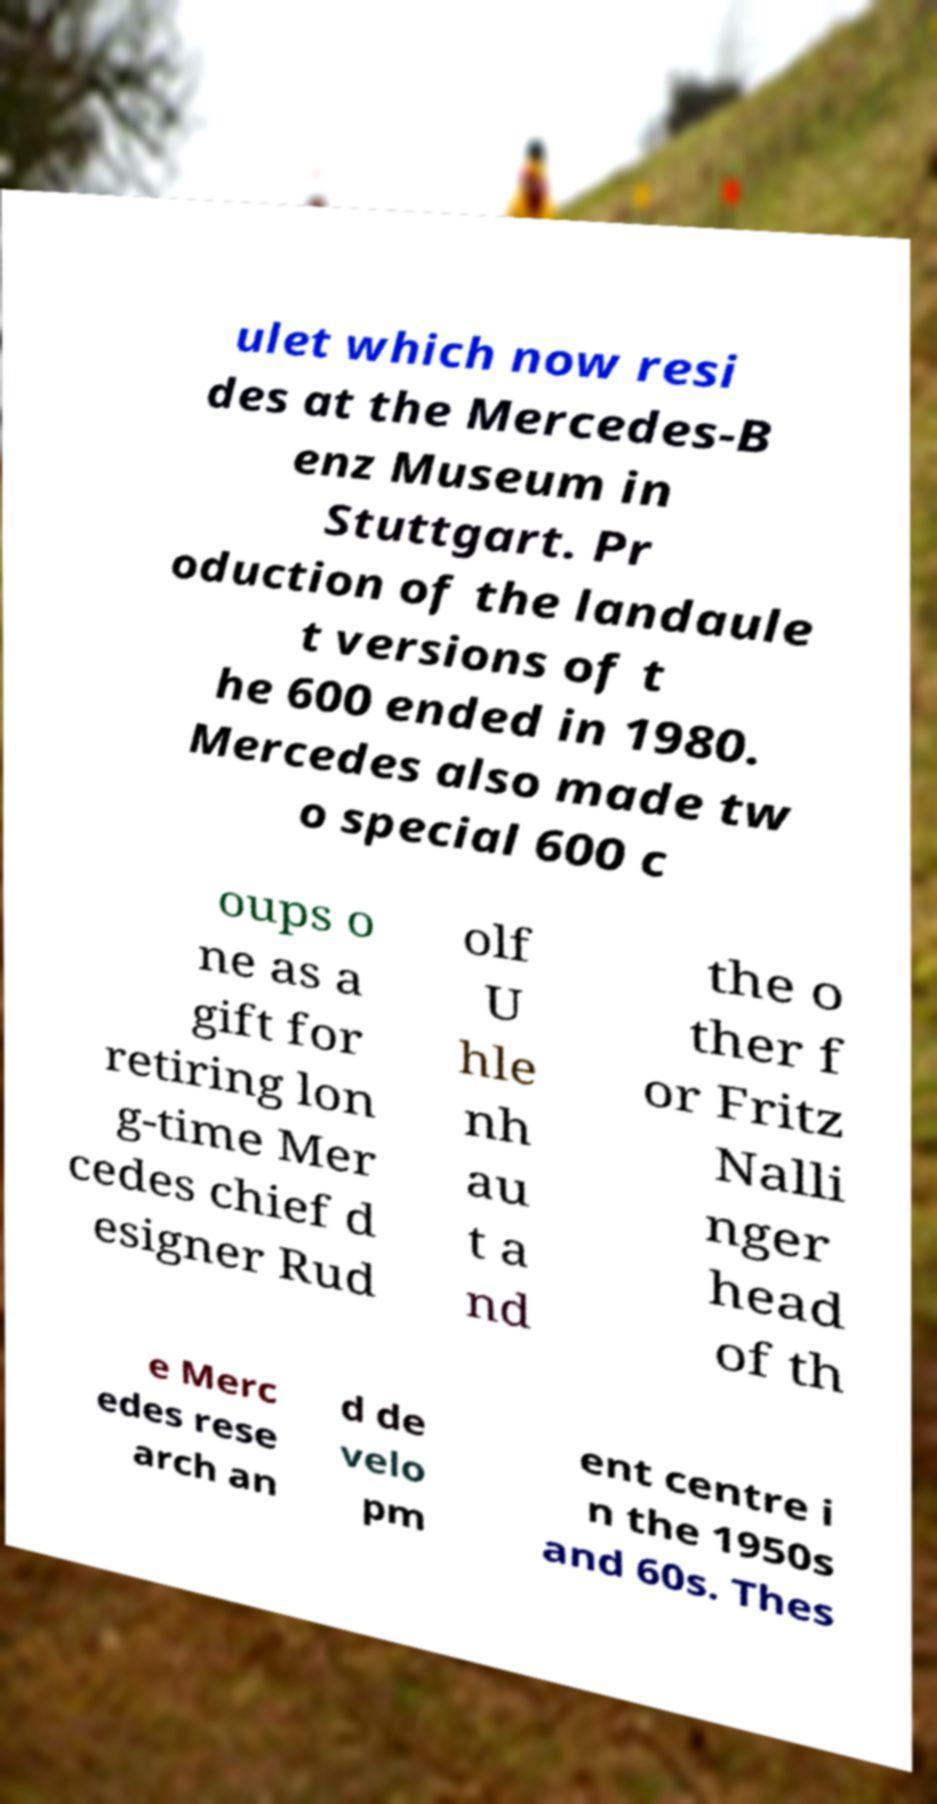I need the written content from this picture converted into text. Can you do that? ulet which now resi des at the Mercedes-B enz Museum in Stuttgart. Pr oduction of the landaule t versions of t he 600 ended in 1980. Mercedes also made tw o special 600 c oups o ne as a gift for retiring lon g-time Mer cedes chief d esigner Rud olf U hle nh au t a nd the o ther f or Fritz Nalli nger head of th e Merc edes rese arch an d de velo pm ent centre i n the 1950s and 60s. Thes 